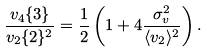<formula> <loc_0><loc_0><loc_500><loc_500>\frac { v _ { 4 } \{ 3 \} } { v _ { 2 } \{ 2 \} ^ { 2 } } = \frac { 1 } { 2 } \left ( 1 + 4 \frac { \sigma _ { v } ^ { 2 } } { \langle v _ { 2 } \rangle ^ { 2 } } \right ) .</formula> 